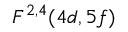<formula> <loc_0><loc_0><loc_500><loc_500>F ^ { 2 , 4 } ( 4 d , 5 f )</formula> 